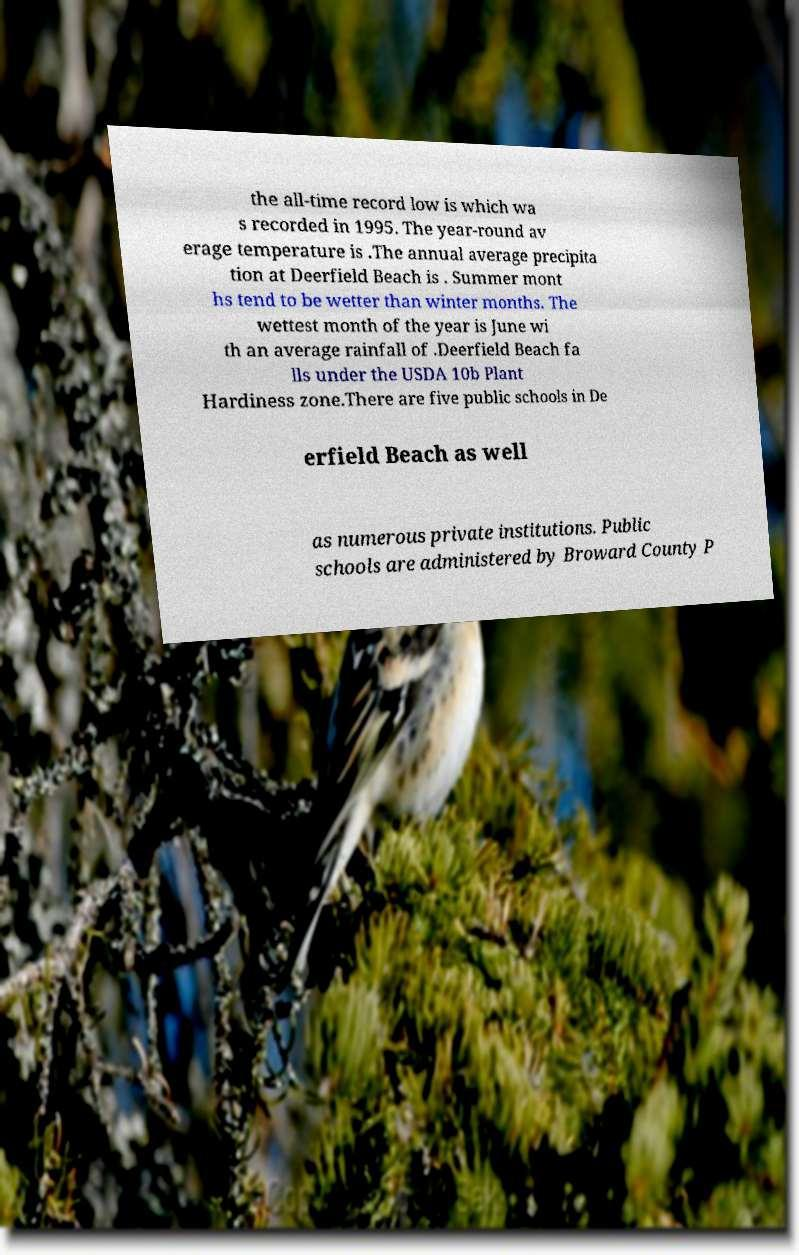Can you accurately transcribe the text from the provided image for me? the all-time record low is which wa s recorded in 1995. The year-round av erage temperature is .The annual average precipita tion at Deerfield Beach is . Summer mont hs tend to be wetter than winter months. The wettest month of the year is June wi th an average rainfall of .Deerfield Beach fa lls under the USDA 10b Plant Hardiness zone.There are five public schools in De erfield Beach as well as numerous private institutions. Public schools are administered by Broward County P 